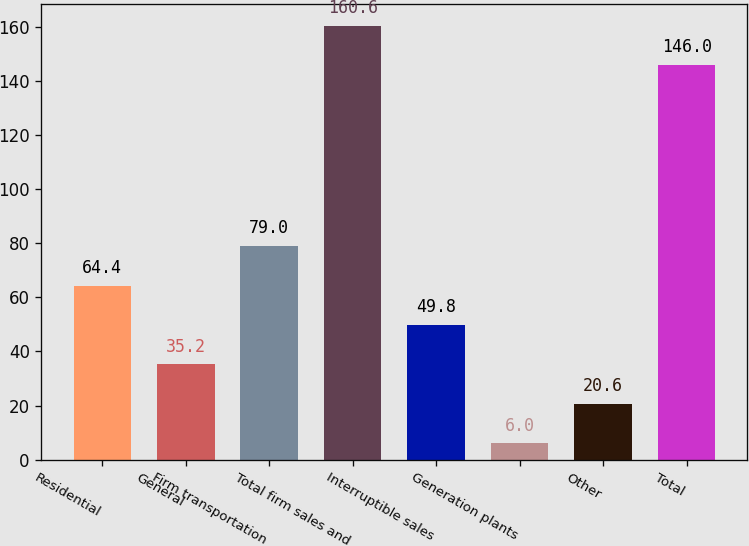Convert chart to OTSL. <chart><loc_0><loc_0><loc_500><loc_500><bar_chart><fcel>Residential<fcel>General<fcel>Firm transportation<fcel>Total firm sales and<fcel>Interruptible sales<fcel>Generation plants<fcel>Other<fcel>Total<nl><fcel>64.4<fcel>35.2<fcel>79<fcel>160.6<fcel>49.8<fcel>6<fcel>20.6<fcel>146<nl></chart> 